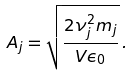Convert formula to latex. <formula><loc_0><loc_0><loc_500><loc_500>A _ { j } = \sqrt { \frac { 2 \nu _ { j } ^ { 2 } m _ { j } } { V \epsilon _ { 0 } } } \, .</formula> 